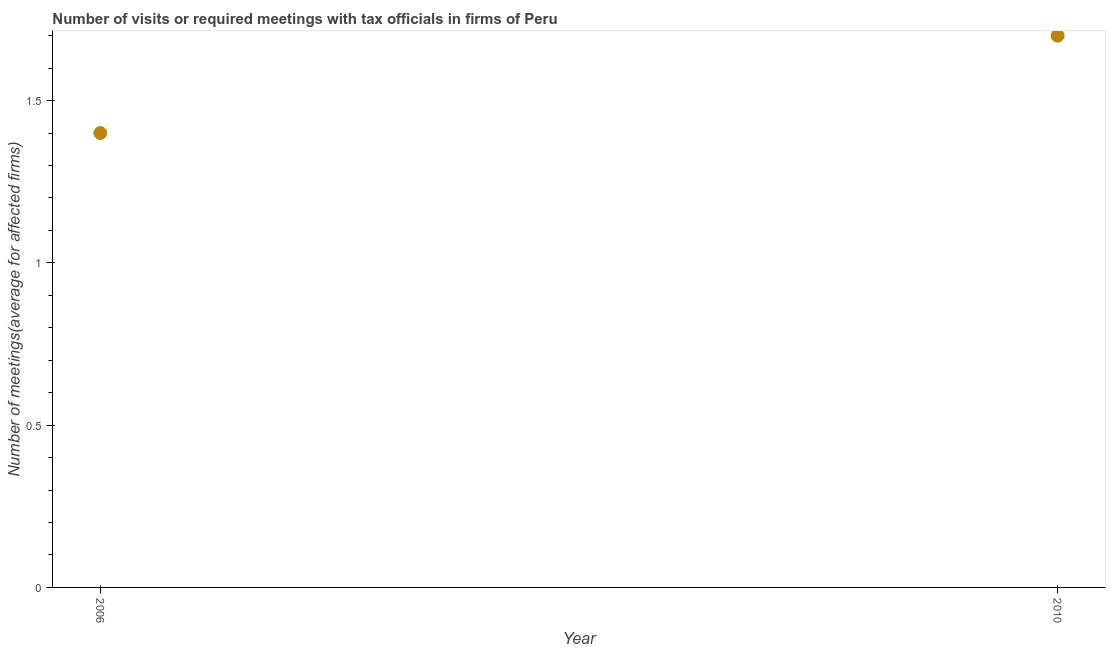Across all years, what is the maximum number of required meetings with tax officials?
Provide a short and direct response. 1.7. Across all years, what is the minimum number of required meetings with tax officials?
Offer a very short reply. 1.4. In which year was the number of required meetings with tax officials maximum?
Provide a short and direct response. 2010. In which year was the number of required meetings with tax officials minimum?
Your answer should be very brief. 2006. What is the sum of the number of required meetings with tax officials?
Offer a terse response. 3.1. What is the difference between the number of required meetings with tax officials in 2006 and 2010?
Offer a very short reply. -0.3. What is the average number of required meetings with tax officials per year?
Give a very brief answer. 1.55. What is the median number of required meetings with tax officials?
Provide a short and direct response. 1.55. What is the ratio of the number of required meetings with tax officials in 2006 to that in 2010?
Provide a succinct answer. 0.82. Is the number of required meetings with tax officials in 2006 less than that in 2010?
Provide a succinct answer. Yes. In how many years, is the number of required meetings with tax officials greater than the average number of required meetings with tax officials taken over all years?
Keep it short and to the point. 1. What is the difference between two consecutive major ticks on the Y-axis?
Offer a very short reply. 0.5. Does the graph contain any zero values?
Make the answer very short. No. What is the title of the graph?
Offer a very short reply. Number of visits or required meetings with tax officials in firms of Peru. What is the label or title of the Y-axis?
Provide a succinct answer. Number of meetings(average for affected firms). What is the Number of meetings(average for affected firms) in 2006?
Your answer should be compact. 1.4. What is the difference between the Number of meetings(average for affected firms) in 2006 and 2010?
Give a very brief answer. -0.3. What is the ratio of the Number of meetings(average for affected firms) in 2006 to that in 2010?
Offer a terse response. 0.82. 